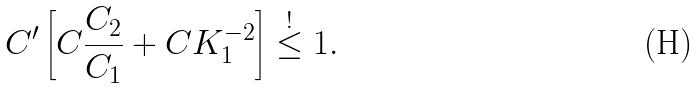<formula> <loc_0><loc_0><loc_500><loc_500>C ^ { \prime } \left [ C \frac { C _ { 2 } } { C _ { 1 } } + C K _ { 1 } ^ { - 2 } \right ] \stackrel { ! } { \leq } 1 .</formula> 